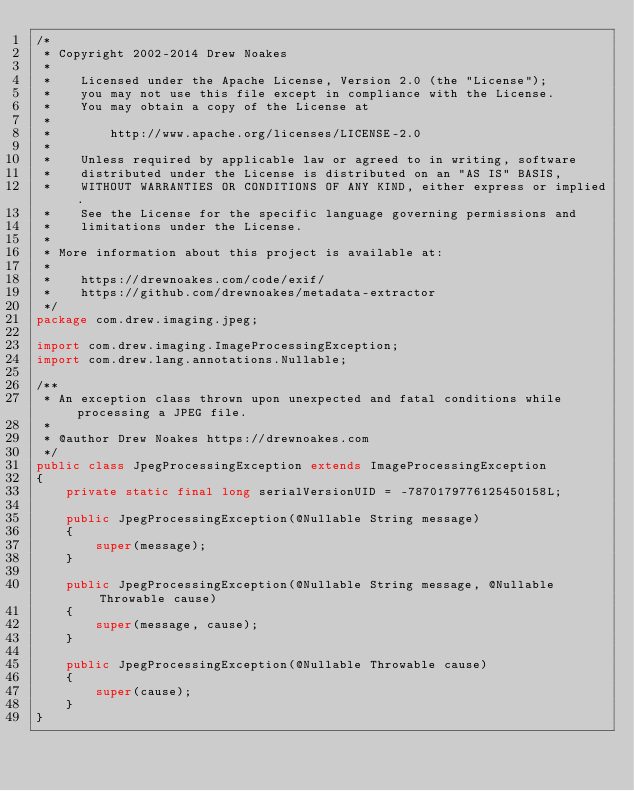<code> <loc_0><loc_0><loc_500><loc_500><_Java_>/*
 * Copyright 2002-2014 Drew Noakes
 *
 *    Licensed under the Apache License, Version 2.0 (the "License");
 *    you may not use this file except in compliance with the License.
 *    You may obtain a copy of the License at
 *
 *        http://www.apache.org/licenses/LICENSE-2.0
 *
 *    Unless required by applicable law or agreed to in writing, software
 *    distributed under the License is distributed on an "AS IS" BASIS,
 *    WITHOUT WARRANTIES OR CONDITIONS OF ANY KIND, either express or implied.
 *    See the License for the specific language governing permissions and
 *    limitations under the License.
 *
 * More information about this project is available at:
 *
 *    https://drewnoakes.com/code/exif/
 *    https://github.com/drewnoakes/metadata-extractor
 */
package com.drew.imaging.jpeg;

import com.drew.imaging.ImageProcessingException;
import com.drew.lang.annotations.Nullable;

/**
 * An exception class thrown upon unexpected and fatal conditions while processing a JPEG file.
 *
 * @author Drew Noakes https://drewnoakes.com
 */
public class JpegProcessingException extends ImageProcessingException
{
    private static final long serialVersionUID = -7870179776125450158L;

    public JpegProcessingException(@Nullable String message)
    {
        super(message);
    }

    public JpegProcessingException(@Nullable String message, @Nullable Throwable cause)
    {
        super(message, cause);
    }

    public JpegProcessingException(@Nullable Throwable cause)
    {
        super(cause);
    }
}
</code> 